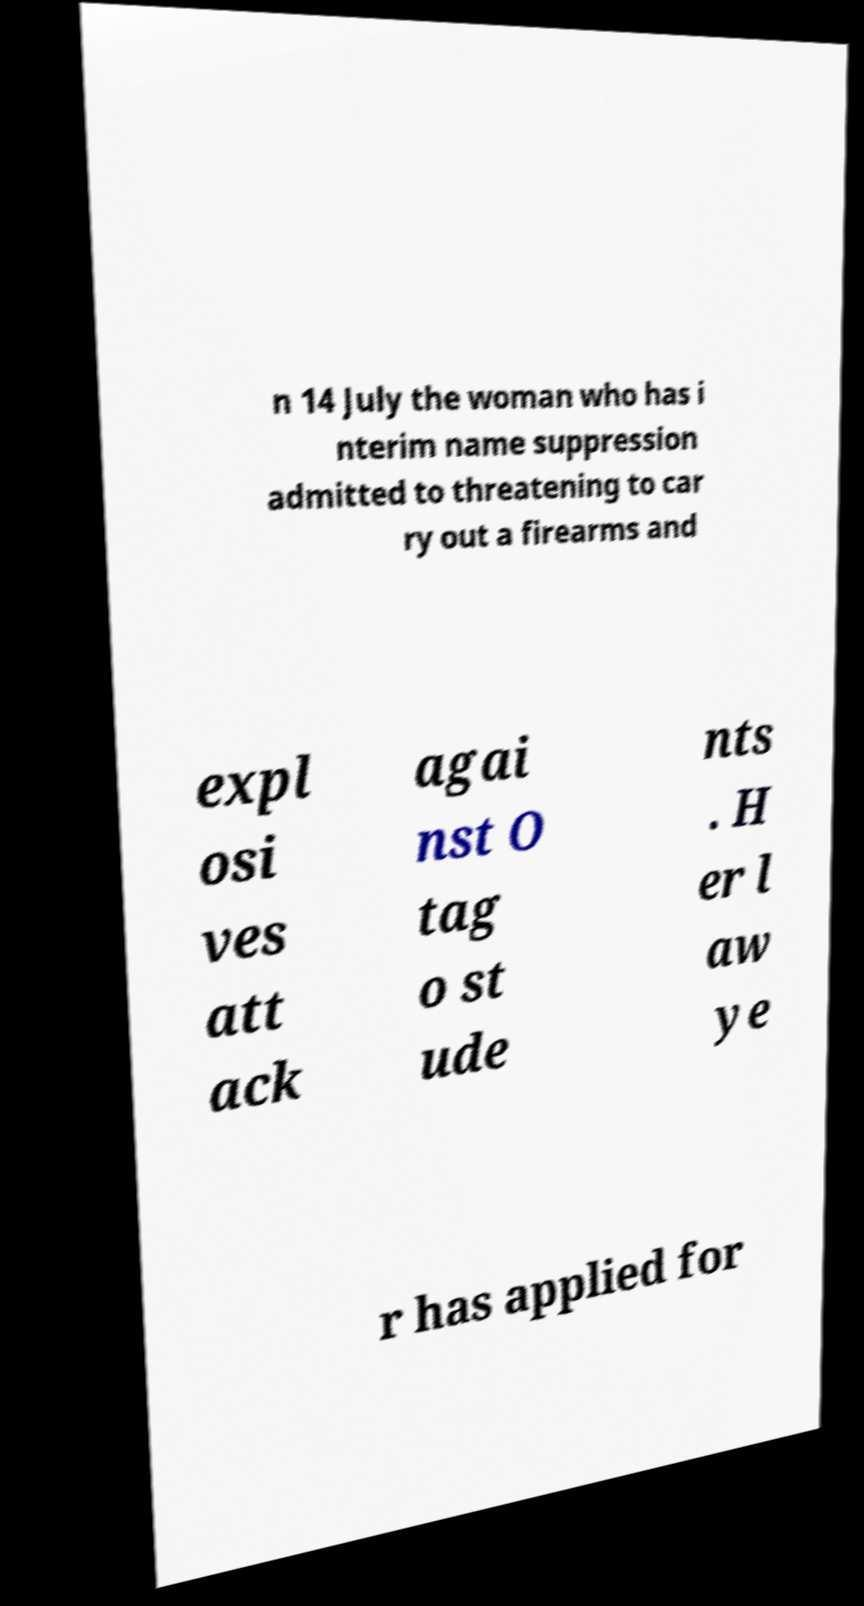Could you assist in decoding the text presented in this image and type it out clearly? n 14 July the woman who has i nterim name suppression admitted to threatening to car ry out a firearms and expl osi ves att ack agai nst O tag o st ude nts . H er l aw ye r has applied for 